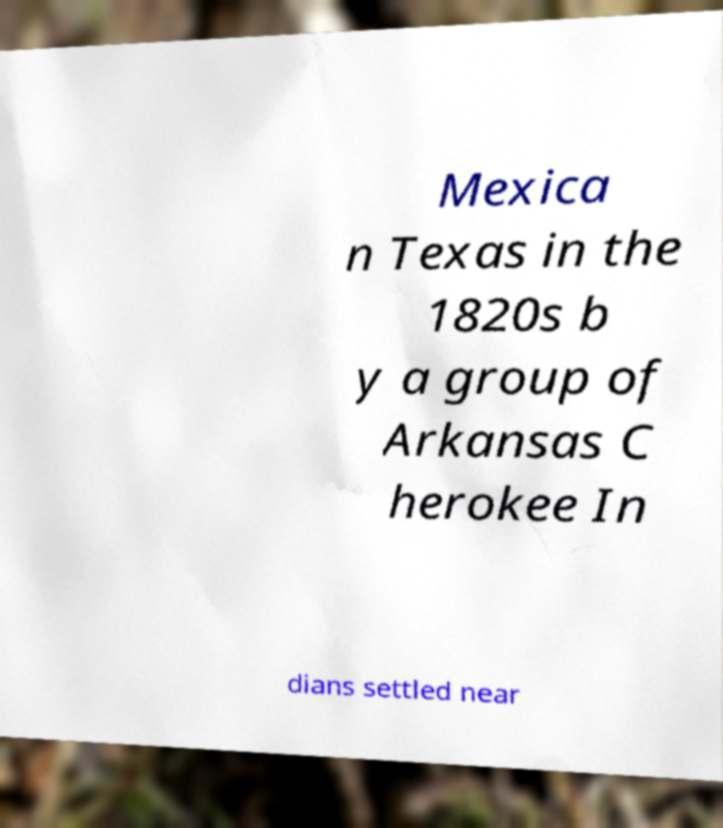Can you read and provide the text displayed in the image?This photo seems to have some interesting text. Can you extract and type it out for me? Mexica n Texas in the 1820s b y a group of Arkansas C herokee In dians settled near 